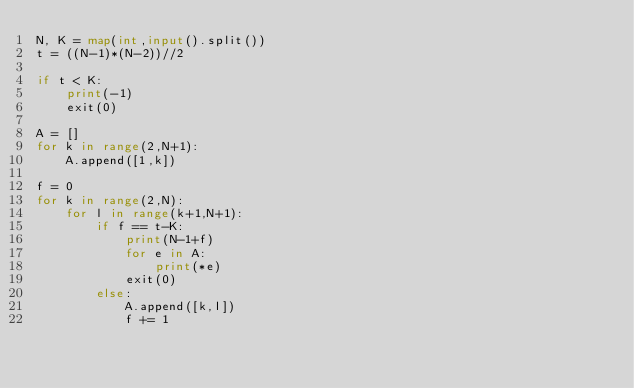Convert code to text. <code><loc_0><loc_0><loc_500><loc_500><_Python_>N, K = map(int,input().split())
t = ((N-1)*(N-2))//2

if t < K:
    print(-1)
    exit(0)

A = []
for k in range(2,N+1):
    A.append([1,k])

f = 0
for k in range(2,N):
    for l in range(k+1,N+1):
        if f == t-K:
            print(N-1+f)
            for e in A:
                print(*e)
            exit(0)
        else:
            A.append([k,l])
            f += 1
</code> 